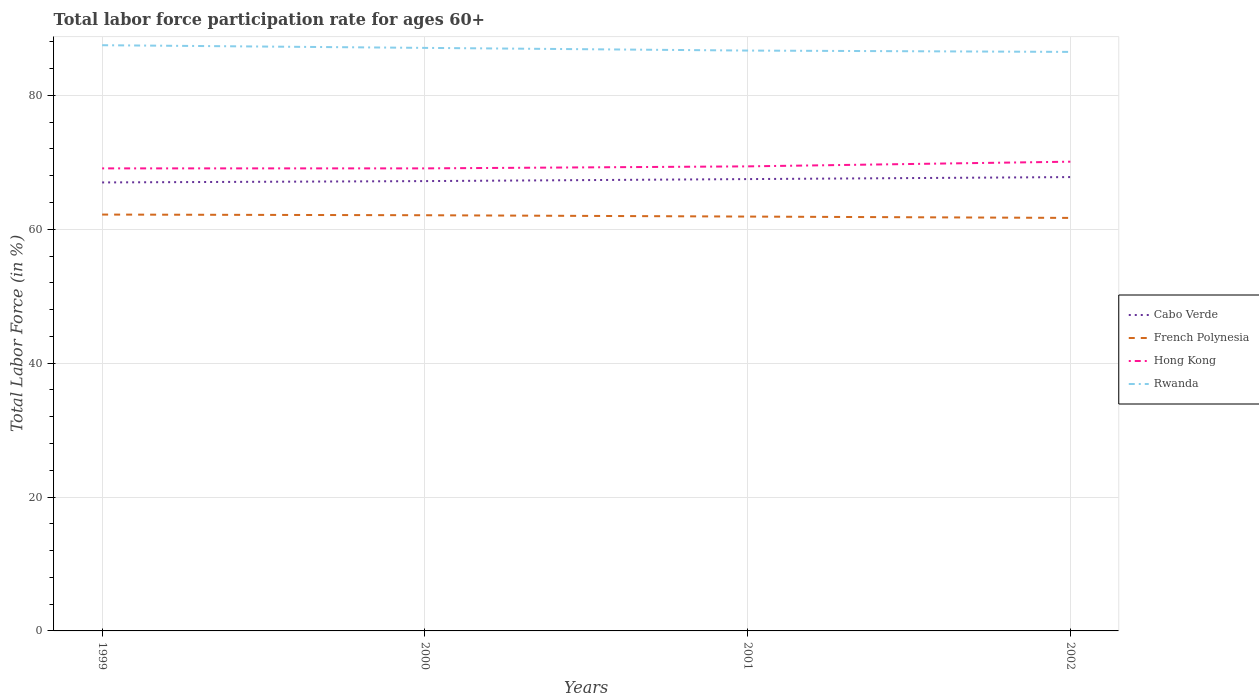How many different coloured lines are there?
Offer a very short reply. 4. Does the line corresponding to Rwanda intersect with the line corresponding to Hong Kong?
Offer a very short reply. No. Is the number of lines equal to the number of legend labels?
Your answer should be compact. Yes. Across all years, what is the maximum labor force participation rate in Cabo Verde?
Provide a succinct answer. 67. In which year was the labor force participation rate in Hong Kong maximum?
Your response must be concise. 1999. What is the difference between the highest and the lowest labor force participation rate in French Polynesia?
Offer a terse response. 2. Is the labor force participation rate in French Polynesia strictly greater than the labor force participation rate in Cabo Verde over the years?
Offer a very short reply. Yes. How many lines are there?
Give a very brief answer. 4. How many years are there in the graph?
Your response must be concise. 4. Are the values on the major ticks of Y-axis written in scientific E-notation?
Provide a succinct answer. No. Does the graph contain any zero values?
Offer a very short reply. No. Does the graph contain grids?
Ensure brevity in your answer.  Yes. Where does the legend appear in the graph?
Provide a succinct answer. Center right. What is the title of the graph?
Give a very brief answer. Total labor force participation rate for ages 60+. Does "Ecuador" appear as one of the legend labels in the graph?
Make the answer very short. No. What is the label or title of the Y-axis?
Your answer should be compact. Total Labor Force (in %). What is the Total Labor Force (in %) of Cabo Verde in 1999?
Your response must be concise. 67. What is the Total Labor Force (in %) of French Polynesia in 1999?
Make the answer very short. 62.2. What is the Total Labor Force (in %) of Hong Kong in 1999?
Offer a terse response. 69.1. What is the Total Labor Force (in %) of Rwanda in 1999?
Give a very brief answer. 87.5. What is the Total Labor Force (in %) of Cabo Verde in 2000?
Provide a succinct answer. 67.2. What is the Total Labor Force (in %) in French Polynesia in 2000?
Your answer should be compact. 62.1. What is the Total Labor Force (in %) of Hong Kong in 2000?
Your response must be concise. 69.1. What is the Total Labor Force (in %) in Rwanda in 2000?
Your response must be concise. 87.1. What is the Total Labor Force (in %) in Cabo Verde in 2001?
Keep it short and to the point. 67.5. What is the Total Labor Force (in %) of French Polynesia in 2001?
Offer a terse response. 61.9. What is the Total Labor Force (in %) in Hong Kong in 2001?
Give a very brief answer. 69.4. What is the Total Labor Force (in %) of Rwanda in 2001?
Your response must be concise. 86.7. What is the Total Labor Force (in %) of Cabo Verde in 2002?
Your answer should be compact. 67.8. What is the Total Labor Force (in %) of French Polynesia in 2002?
Provide a short and direct response. 61.7. What is the Total Labor Force (in %) in Hong Kong in 2002?
Provide a succinct answer. 70.1. What is the Total Labor Force (in %) of Rwanda in 2002?
Your response must be concise. 86.5. Across all years, what is the maximum Total Labor Force (in %) of Cabo Verde?
Your response must be concise. 67.8. Across all years, what is the maximum Total Labor Force (in %) in French Polynesia?
Your answer should be very brief. 62.2. Across all years, what is the maximum Total Labor Force (in %) in Hong Kong?
Offer a terse response. 70.1. Across all years, what is the maximum Total Labor Force (in %) in Rwanda?
Provide a succinct answer. 87.5. Across all years, what is the minimum Total Labor Force (in %) in Cabo Verde?
Provide a succinct answer. 67. Across all years, what is the minimum Total Labor Force (in %) of French Polynesia?
Provide a short and direct response. 61.7. Across all years, what is the minimum Total Labor Force (in %) in Hong Kong?
Your answer should be compact. 69.1. Across all years, what is the minimum Total Labor Force (in %) of Rwanda?
Provide a succinct answer. 86.5. What is the total Total Labor Force (in %) of Cabo Verde in the graph?
Your answer should be compact. 269.5. What is the total Total Labor Force (in %) in French Polynesia in the graph?
Offer a very short reply. 247.9. What is the total Total Labor Force (in %) in Hong Kong in the graph?
Your answer should be compact. 277.7. What is the total Total Labor Force (in %) of Rwanda in the graph?
Ensure brevity in your answer.  347.8. What is the difference between the Total Labor Force (in %) in Cabo Verde in 1999 and that in 2000?
Make the answer very short. -0.2. What is the difference between the Total Labor Force (in %) in French Polynesia in 1999 and that in 2000?
Make the answer very short. 0.1. What is the difference between the Total Labor Force (in %) in Rwanda in 1999 and that in 2000?
Offer a terse response. 0.4. What is the difference between the Total Labor Force (in %) in Rwanda in 1999 and that in 2002?
Give a very brief answer. 1. What is the difference between the Total Labor Force (in %) in Cabo Verde in 2000 and that in 2001?
Provide a succinct answer. -0.3. What is the difference between the Total Labor Force (in %) in French Polynesia in 2000 and that in 2001?
Keep it short and to the point. 0.2. What is the difference between the Total Labor Force (in %) in Hong Kong in 2000 and that in 2001?
Make the answer very short. -0.3. What is the difference between the Total Labor Force (in %) in Rwanda in 2000 and that in 2002?
Offer a terse response. 0.6. What is the difference between the Total Labor Force (in %) of Cabo Verde in 2001 and that in 2002?
Keep it short and to the point. -0.3. What is the difference between the Total Labor Force (in %) of French Polynesia in 2001 and that in 2002?
Give a very brief answer. 0.2. What is the difference between the Total Labor Force (in %) in Rwanda in 2001 and that in 2002?
Your answer should be compact. 0.2. What is the difference between the Total Labor Force (in %) in Cabo Verde in 1999 and the Total Labor Force (in %) in Rwanda in 2000?
Your answer should be compact. -20.1. What is the difference between the Total Labor Force (in %) of French Polynesia in 1999 and the Total Labor Force (in %) of Rwanda in 2000?
Make the answer very short. -24.9. What is the difference between the Total Labor Force (in %) in Cabo Verde in 1999 and the Total Labor Force (in %) in French Polynesia in 2001?
Give a very brief answer. 5.1. What is the difference between the Total Labor Force (in %) of Cabo Verde in 1999 and the Total Labor Force (in %) of Hong Kong in 2001?
Your answer should be compact. -2.4. What is the difference between the Total Labor Force (in %) of Cabo Verde in 1999 and the Total Labor Force (in %) of Rwanda in 2001?
Your response must be concise. -19.7. What is the difference between the Total Labor Force (in %) of French Polynesia in 1999 and the Total Labor Force (in %) of Rwanda in 2001?
Your answer should be very brief. -24.5. What is the difference between the Total Labor Force (in %) in Hong Kong in 1999 and the Total Labor Force (in %) in Rwanda in 2001?
Your answer should be compact. -17.6. What is the difference between the Total Labor Force (in %) in Cabo Verde in 1999 and the Total Labor Force (in %) in French Polynesia in 2002?
Provide a succinct answer. 5.3. What is the difference between the Total Labor Force (in %) in Cabo Verde in 1999 and the Total Labor Force (in %) in Hong Kong in 2002?
Make the answer very short. -3.1. What is the difference between the Total Labor Force (in %) of Cabo Verde in 1999 and the Total Labor Force (in %) of Rwanda in 2002?
Provide a succinct answer. -19.5. What is the difference between the Total Labor Force (in %) in French Polynesia in 1999 and the Total Labor Force (in %) in Hong Kong in 2002?
Your answer should be compact. -7.9. What is the difference between the Total Labor Force (in %) of French Polynesia in 1999 and the Total Labor Force (in %) of Rwanda in 2002?
Make the answer very short. -24.3. What is the difference between the Total Labor Force (in %) of Hong Kong in 1999 and the Total Labor Force (in %) of Rwanda in 2002?
Keep it short and to the point. -17.4. What is the difference between the Total Labor Force (in %) in Cabo Verde in 2000 and the Total Labor Force (in %) in Rwanda in 2001?
Give a very brief answer. -19.5. What is the difference between the Total Labor Force (in %) in French Polynesia in 2000 and the Total Labor Force (in %) in Hong Kong in 2001?
Offer a very short reply. -7.3. What is the difference between the Total Labor Force (in %) of French Polynesia in 2000 and the Total Labor Force (in %) of Rwanda in 2001?
Your answer should be very brief. -24.6. What is the difference between the Total Labor Force (in %) in Hong Kong in 2000 and the Total Labor Force (in %) in Rwanda in 2001?
Give a very brief answer. -17.6. What is the difference between the Total Labor Force (in %) of Cabo Verde in 2000 and the Total Labor Force (in %) of Rwanda in 2002?
Provide a succinct answer. -19.3. What is the difference between the Total Labor Force (in %) in French Polynesia in 2000 and the Total Labor Force (in %) in Hong Kong in 2002?
Give a very brief answer. -8. What is the difference between the Total Labor Force (in %) in French Polynesia in 2000 and the Total Labor Force (in %) in Rwanda in 2002?
Your answer should be compact. -24.4. What is the difference between the Total Labor Force (in %) of Hong Kong in 2000 and the Total Labor Force (in %) of Rwanda in 2002?
Your response must be concise. -17.4. What is the difference between the Total Labor Force (in %) of Cabo Verde in 2001 and the Total Labor Force (in %) of French Polynesia in 2002?
Keep it short and to the point. 5.8. What is the difference between the Total Labor Force (in %) of Cabo Verde in 2001 and the Total Labor Force (in %) of Rwanda in 2002?
Ensure brevity in your answer.  -19. What is the difference between the Total Labor Force (in %) in French Polynesia in 2001 and the Total Labor Force (in %) in Hong Kong in 2002?
Give a very brief answer. -8.2. What is the difference between the Total Labor Force (in %) in French Polynesia in 2001 and the Total Labor Force (in %) in Rwanda in 2002?
Give a very brief answer. -24.6. What is the difference between the Total Labor Force (in %) in Hong Kong in 2001 and the Total Labor Force (in %) in Rwanda in 2002?
Keep it short and to the point. -17.1. What is the average Total Labor Force (in %) in Cabo Verde per year?
Make the answer very short. 67.38. What is the average Total Labor Force (in %) of French Polynesia per year?
Ensure brevity in your answer.  61.98. What is the average Total Labor Force (in %) of Hong Kong per year?
Provide a succinct answer. 69.42. What is the average Total Labor Force (in %) of Rwanda per year?
Your answer should be very brief. 86.95. In the year 1999, what is the difference between the Total Labor Force (in %) of Cabo Verde and Total Labor Force (in %) of French Polynesia?
Make the answer very short. 4.8. In the year 1999, what is the difference between the Total Labor Force (in %) of Cabo Verde and Total Labor Force (in %) of Rwanda?
Your response must be concise. -20.5. In the year 1999, what is the difference between the Total Labor Force (in %) in French Polynesia and Total Labor Force (in %) in Rwanda?
Offer a terse response. -25.3. In the year 1999, what is the difference between the Total Labor Force (in %) in Hong Kong and Total Labor Force (in %) in Rwanda?
Your answer should be very brief. -18.4. In the year 2000, what is the difference between the Total Labor Force (in %) of Cabo Verde and Total Labor Force (in %) of French Polynesia?
Provide a succinct answer. 5.1. In the year 2000, what is the difference between the Total Labor Force (in %) in Cabo Verde and Total Labor Force (in %) in Rwanda?
Provide a succinct answer. -19.9. In the year 2000, what is the difference between the Total Labor Force (in %) of French Polynesia and Total Labor Force (in %) of Hong Kong?
Your answer should be very brief. -7. In the year 2000, what is the difference between the Total Labor Force (in %) in French Polynesia and Total Labor Force (in %) in Rwanda?
Your answer should be very brief. -25. In the year 2001, what is the difference between the Total Labor Force (in %) of Cabo Verde and Total Labor Force (in %) of Hong Kong?
Provide a short and direct response. -1.9. In the year 2001, what is the difference between the Total Labor Force (in %) in Cabo Verde and Total Labor Force (in %) in Rwanda?
Your response must be concise. -19.2. In the year 2001, what is the difference between the Total Labor Force (in %) in French Polynesia and Total Labor Force (in %) in Hong Kong?
Your response must be concise. -7.5. In the year 2001, what is the difference between the Total Labor Force (in %) in French Polynesia and Total Labor Force (in %) in Rwanda?
Your answer should be very brief. -24.8. In the year 2001, what is the difference between the Total Labor Force (in %) of Hong Kong and Total Labor Force (in %) of Rwanda?
Make the answer very short. -17.3. In the year 2002, what is the difference between the Total Labor Force (in %) in Cabo Verde and Total Labor Force (in %) in French Polynesia?
Make the answer very short. 6.1. In the year 2002, what is the difference between the Total Labor Force (in %) of Cabo Verde and Total Labor Force (in %) of Rwanda?
Your answer should be compact. -18.7. In the year 2002, what is the difference between the Total Labor Force (in %) in French Polynesia and Total Labor Force (in %) in Hong Kong?
Offer a very short reply. -8.4. In the year 2002, what is the difference between the Total Labor Force (in %) in French Polynesia and Total Labor Force (in %) in Rwanda?
Your answer should be compact. -24.8. In the year 2002, what is the difference between the Total Labor Force (in %) in Hong Kong and Total Labor Force (in %) in Rwanda?
Provide a succinct answer. -16.4. What is the ratio of the Total Labor Force (in %) of Cabo Verde in 1999 to that in 2000?
Your response must be concise. 1. What is the ratio of the Total Labor Force (in %) of Hong Kong in 1999 to that in 2000?
Your answer should be very brief. 1. What is the ratio of the Total Labor Force (in %) in Rwanda in 1999 to that in 2000?
Your answer should be compact. 1. What is the ratio of the Total Labor Force (in %) in French Polynesia in 1999 to that in 2001?
Offer a very short reply. 1. What is the ratio of the Total Labor Force (in %) in Rwanda in 1999 to that in 2001?
Give a very brief answer. 1.01. What is the ratio of the Total Labor Force (in %) of French Polynesia in 1999 to that in 2002?
Your answer should be very brief. 1.01. What is the ratio of the Total Labor Force (in %) of Hong Kong in 1999 to that in 2002?
Make the answer very short. 0.99. What is the ratio of the Total Labor Force (in %) in Rwanda in 1999 to that in 2002?
Make the answer very short. 1.01. What is the ratio of the Total Labor Force (in %) of Hong Kong in 2000 to that in 2002?
Make the answer very short. 0.99. What is the ratio of the Total Labor Force (in %) in Rwanda in 2000 to that in 2002?
Give a very brief answer. 1.01. What is the difference between the highest and the second highest Total Labor Force (in %) of Cabo Verde?
Your response must be concise. 0.3. What is the difference between the highest and the second highest Total Labor Force (in %) of Hong Kong?
Keep it short and to the point. 0.7. What is the difference between the highest and the second highest Total Labor Force (in %) of Rwanda?
Offer a terse response. 0.4. What is the difference between the highest and the lowest Total Labor Force (in %) of French Polynesia?
Provide a succinct answer. 0.5. 